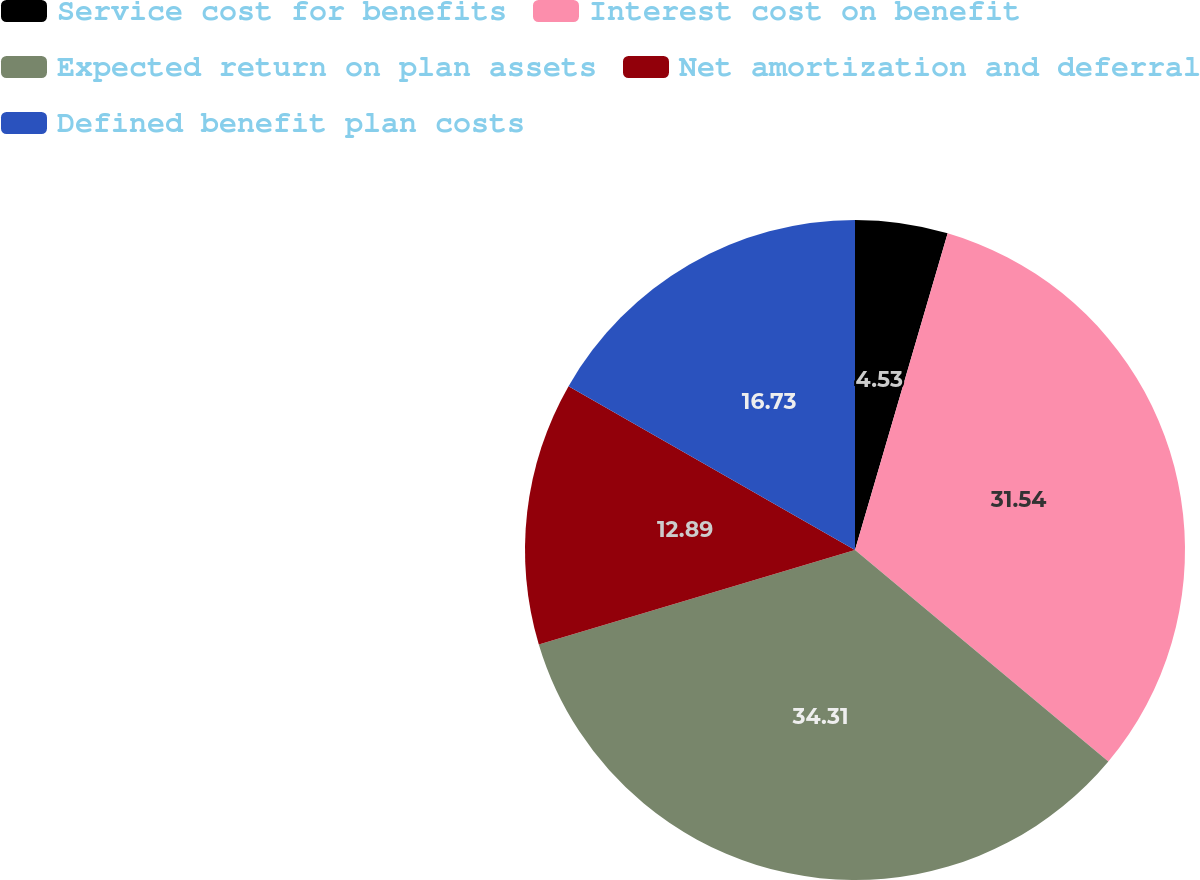Convert chart to OTSL. <chart><loc_0><loc_0><loc_500><loc_500><pie_chart><fcel>Service cost for benefits<fcel>Interest cost on benefit<fcel>Expected return on plan assets<fcel>Net amortization and deferral<fcel>Defined benefit plan costs<nl><fcel>4.53%<fcel>31.54%<fcel>34.31%<fcel>12.89%<fcel>16.73%<nl></chart> 